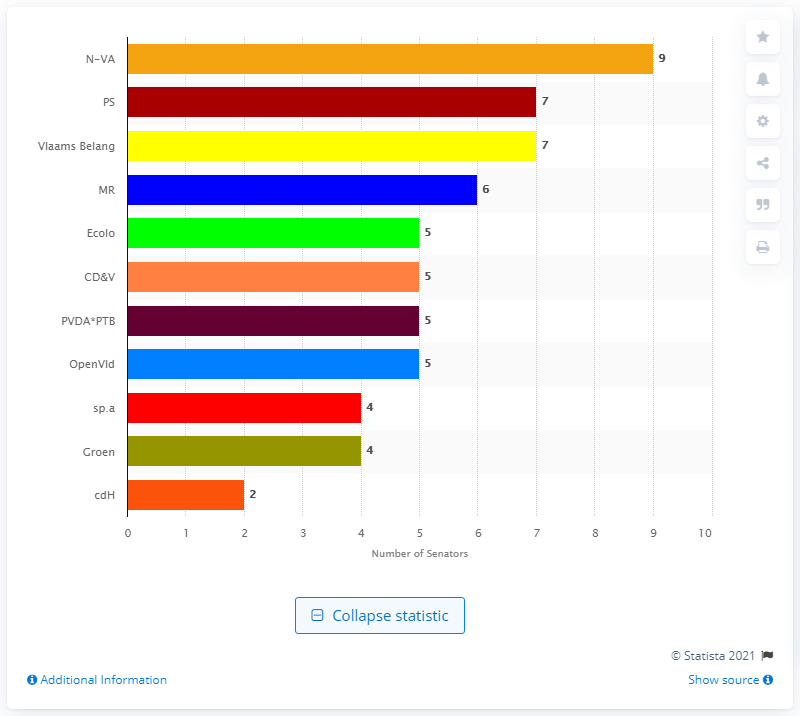List a handful of essential elements in this visual. Vlaams Belang, a Flemish political party, gained seven seats in the senate in the 2019 elections. The Flemish nationalist party's name is N-VA. 